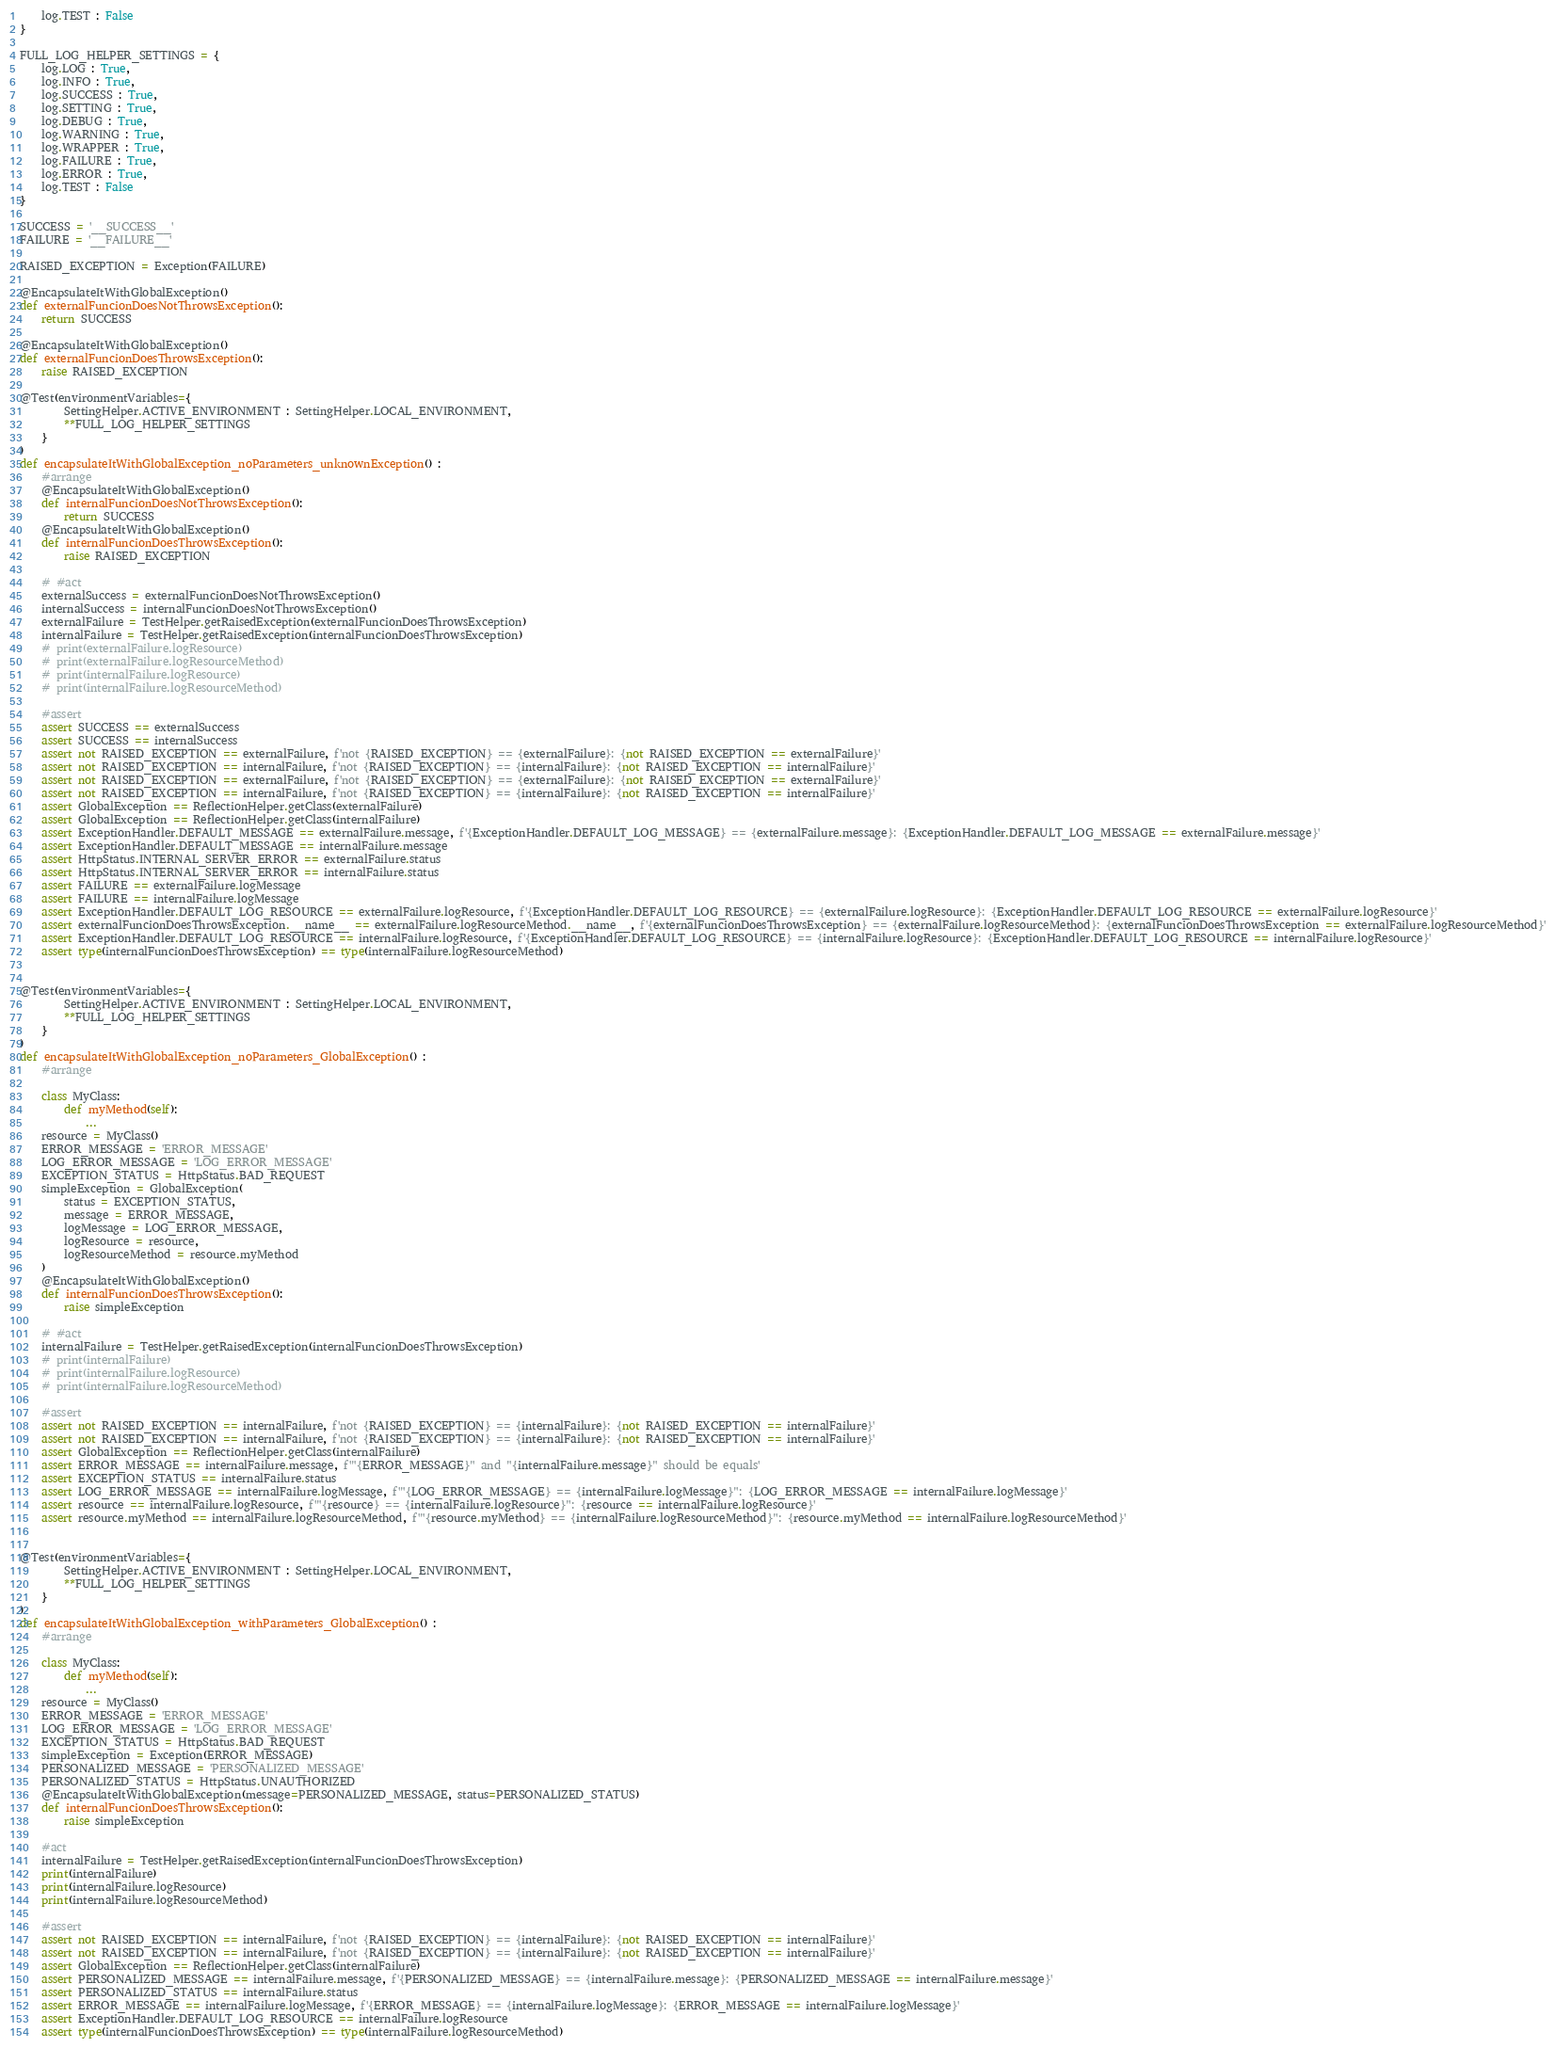<code> <loc_0><loc_0><loc_500><loc_500><_Python_>    log.TEST : False
}

FULL_LOG_HELPER_SETTINGS = {
    log.LOG : True,
    log.INFO : True,
    log.SUCCESS : True,
    log.SETTING : True,
    log.DEBUG : True,
    log.WARNING : True,
    log.WRAPPER : True,
    log.FAILURE : True,
    log.ERROR : True,
    log.TEST : False
}

SUCCESS = '__SUCCESS__'
FAILURE = '__FAILURE__'

RAISED_EXCEPTION = Exception(FAILURE)

@EncapsulateItWithGlobalException()
def externalFuncionDoesNotThrowsException():
    return SUCCESS

@EncapsulateItWithGlobalException()
def externalFuncionDoesThrowsException():
    raise RAISED_EXCEPTION

@Test(environmentVariables={
        SettingHelper.ACTIVE_ENVIRONMENT : SettingHelper.LOCAL_ENVIRONMENT,
        **FULL_LOG_HELPER_SETTINGS
    }
)
def encapsulateItWithGlobalException_noParameters_unknownException() :
    #arrange
    @EncapsulateItWithGlobalException()
    def internalFuncionDoesNotThrowsException():
        return SUCCESS
    @EncapsulateItWithGlobalException()
    def internalFuncionDoesThrowsException():
        raise RAISED_EXCEPTION

    # #act
    externalSuccess = externalFuncionDoesNotThrowsException()
    internalSuccess = internalFuncionDoesNotThrowsException()
    externalFailure = TestHelper.getRaisedException(externalFuncionDoesThrowsException)
    internalFailure = TestHelper.getRaisedException(internalFuncionDoesThrowsException)
    # print(externalFailure.logResource)
    # print(externalFailure.logResourceMethod)
    # print(internalFailure.logResource)
    # print(internalFailure.logResourceMethod)

    #assert
    assert SUCCESS == externalSuccess
    assert SUCCESS == internalSuccess
    assert not RAISED_EXCEPTION == externalFailure, f'not {RAISED_EXCEPTION} == {externalFailure}: {not RAISED_EXCEPTION == externalFailure}'
    assert not RAISED_EXCEPTION == internalFailure, f'not {RAISED_EXCEPTION} == {internalFailure}: {not RAISED_EXCEPTION == internalFailure}'
    assert not RAISED_EXCEPTION == externalFailure, f'not {RAISED_EXCEPTION} == {externalFailure}: {not RAISED_EXCEPTION == externalFailure}'
    assert not RAISED_EXCEPTION == internalFailure, f'not {RAISED_EXCEPTION} == {internalFailure}: {not RAISED_EXCEPTION == internalFailure}'
    assert GlobalException == ReflectionHelper.getClass(externalFailure)
    assert GlobalException == ReflectionHelper.getClass(internalFailure)
    assert ExceptionHandler.DEFAULT_MESSAGE == externalFailure.message, f'{ExceptionHandler.DEFAULT_LOG_MESSAGE} == {externalFailure.message}: {ExceptionHandler.DEFAULT_LOG_MESSAGE == externalFailure.message}'
    assert ExceptionHandler.DEFAULT_MESSAGE == internalFailure.message
    assert HttpStatus.INTERNAL_SERVER_ERROR == externalFailure.status
    assert HttpStatus.INTERNAL_SERVER_ERROR == internalFailure.status
    assert FAILURE == externalFailure.logMessage
    assert FAILURE == internalFailure.logMessage
    assert ExceptionHandler.DEFAULT_LOG_RESOURCE == externalFailure.logResource, f'{ExceptionHandler.DEFAULT_LOG_RESOURCE} == {externalFailure.logResource}: {ExceptionHandler.DEFAULT_LOG_RESOURCE == externalFailure.logResource}'
    assert externalFuncionDoesThrowsException.__name__ == externalFailure.logResourceMethod.__name__, f'{externalFuncionDoesThrowsException} == {externalFailure.logResourceMethod}: {externalFuncionDoesThrowsException == externalFailure.logResourceMethod}'
    assert ExceptionHandler.DEFAULT_LOG_RESOURCE == internalFailure.logResource, f'{ExceptionHandler.DEFAULT_LOG_RESOURCE} == {internalFailure.logResource}: {ExceptionHandler.DEFAULT_LOG_RESOURCE == internalFailure.logResource}'
    assert type(internalFuncionDoesThrowsException) == type(internalFailure.logResourceMethod)


@Test(environmentVariables={
        SettingHelper.ACTIVE_ENVIRONMENT : SettingHelper.LOCAL_ENVIRONMENT,
        **FULL_LOG_HELPER_SETTINGS
    }
)
def encapsulateItWithGlobalException_noParameters_GlobalException() :
    #arrange

    class MyClass:
        def myMethod(self):
            ...
    resource = MyClass()
    ERROR_MESSAGE = 'ERROR_MESSAGE'
    LOG_ERROR_MESSAGE = 'LOG_ERROR_MESSAGE'
    EXCEPTION_STATUS = HttpStatus.BAD_REQUEST
    simpleException = GlobalException(
        status = EXCEPTION_STATUS,
        message = ERROR_MESSAGE,
        logMessage = LOG_ERROR_MESSAGE,
        logResource = resource,
        logResourceMethod = resource.myMethod
    )
    @EncapsulateItWithGlobalException()
    def internalFuncionDoesThrowsException():
        raise simpleException

    # #act
    internalFailure = TestHelper.getRaisedException(internalFuncionDoesThrowsException)
    # print(internalFailure)
    # print(internalFailure.logResource)
    # print(internalFailure.logResourceMethod)

    #assert
    assert not RAISED_EXCEPTION == internalFailure, f'not {RAISED_EXCEPTION} == {internalFailure}: {not RAISED_EXCEPTION == internalFailure}'
    assert not RAISED_EXCEPTION == internalFailure, f'not {RAISED_EXCEPTION} == {internalFailure}: {not RAISED_EXCEPTION == internalFailure}'
    assert GlobalException == ReflectionHelper.getClass(internalFailure)
    assert ERROR_MESSAGE == internalFailure.message, f'"{ERROR_MESSAGE}" and "{internalFailure.message}" should be equals'
    assert EXCEPTION_STATUS == internalFailure.status
    assert LOG_ERROR_MESSAGE == internalFailure.logMessage, f'"{LOG_ERROR_MESSAGE} == {internalFailure.logMessage}": {LOG_ERROR_MESSAGE == internalFailure.logMessage}'
    assert resource == internalFailure.logResource, f'"{resource} == {internalFailure.logResource}": {resource == internalFailure.logResource}'
    assert resource.myMethod == internalFailure.logResourceMethod, f'"{resource.myMethod} == {internalFailure.logResourceMethod}": {resource.myMethod == internalFailure.logResourceMethod}'


@Test(environmentVariables={
        SettingHelper.ACTIVE_ENVIRONMENT : SettingHelper.LOCAL_ENVIRONMENT,
        **FULL_LOG_HELPER_SETTINGS
    }
)
def encapsulateItWithGlobalException_withParameters_GlobalException() :
    #arrange

    class MyClass:
        def myMethod(self):
            ...
    resource = MyClass()
    ERROR_MESSAGE = 'ERROR_MESSAGE'
    LOG_ERROR_MESSAGE = 'LOG_ERROR_MESSAGE'
    EXCEPTION_STATUS = HttpStatus.BAD_REQUEST
    simpleException = Exception(ERROR_MESSAGE)
    PERSONALIZED_MESSAGE = 'PERSONALIZED_MESSAGE'
    PERSONALIZED_STATUS = HttpStatus.UNAUTHORIZED
    @EncapsulateItWithGlobalException(message=PERSONALIZED_MESSAGE, status=PERSONALIZED_STATUS)
    def internalFuncionDoesThrowsException():
        raise simpleException

    #act
    internalFailure = TestHelper.getRaisedException(internalFuncionDoesThrowsException)
    print(internalFailure)
    print(internalFailure.logResource)
    print(internalFailure.logResourceMethod)

    #assert
    assert not RAISED_EXCEPTION == internalFailure, f'not {RAISED_EXCEPTION} == {internalFailure}: {not RAISED_EXCEPTION == internalFailure}'
    assert not RAISED_EXCEPTION == internalFailure, f'not {RAISED_EXCEPTION} == {internalFailure}: {not RAISED_EXCEPTION == internalFailure}'
    assert GlobalException == ReflectionHelper.getClass(internalFailure)
    assert PERSONALIZED_MESSAGE == internalFailure.message, f'{PERSONALIZED_MESSAGE} == {internalFailure.message}: {PERSONALIZED_MESSAGE == internalFailure.message}'
    assert PERSONALIZED_STATUS == internalFailure.status
    assert ERROR_MESSAGE == internalFailure.logMessage, f'{ERROR_MESSAGE} == {internalFailure.logMessage}: {ERROR_MESSAGE == internalFailure.logMessage}'
    assert ExceptionHandler.DEFAULT_LOG_RESOURCE == internalFailure.logResource
    assert type(internalFuncionDoesThrowsException) == type(internalFailure.logResourceMethod)
</code> 